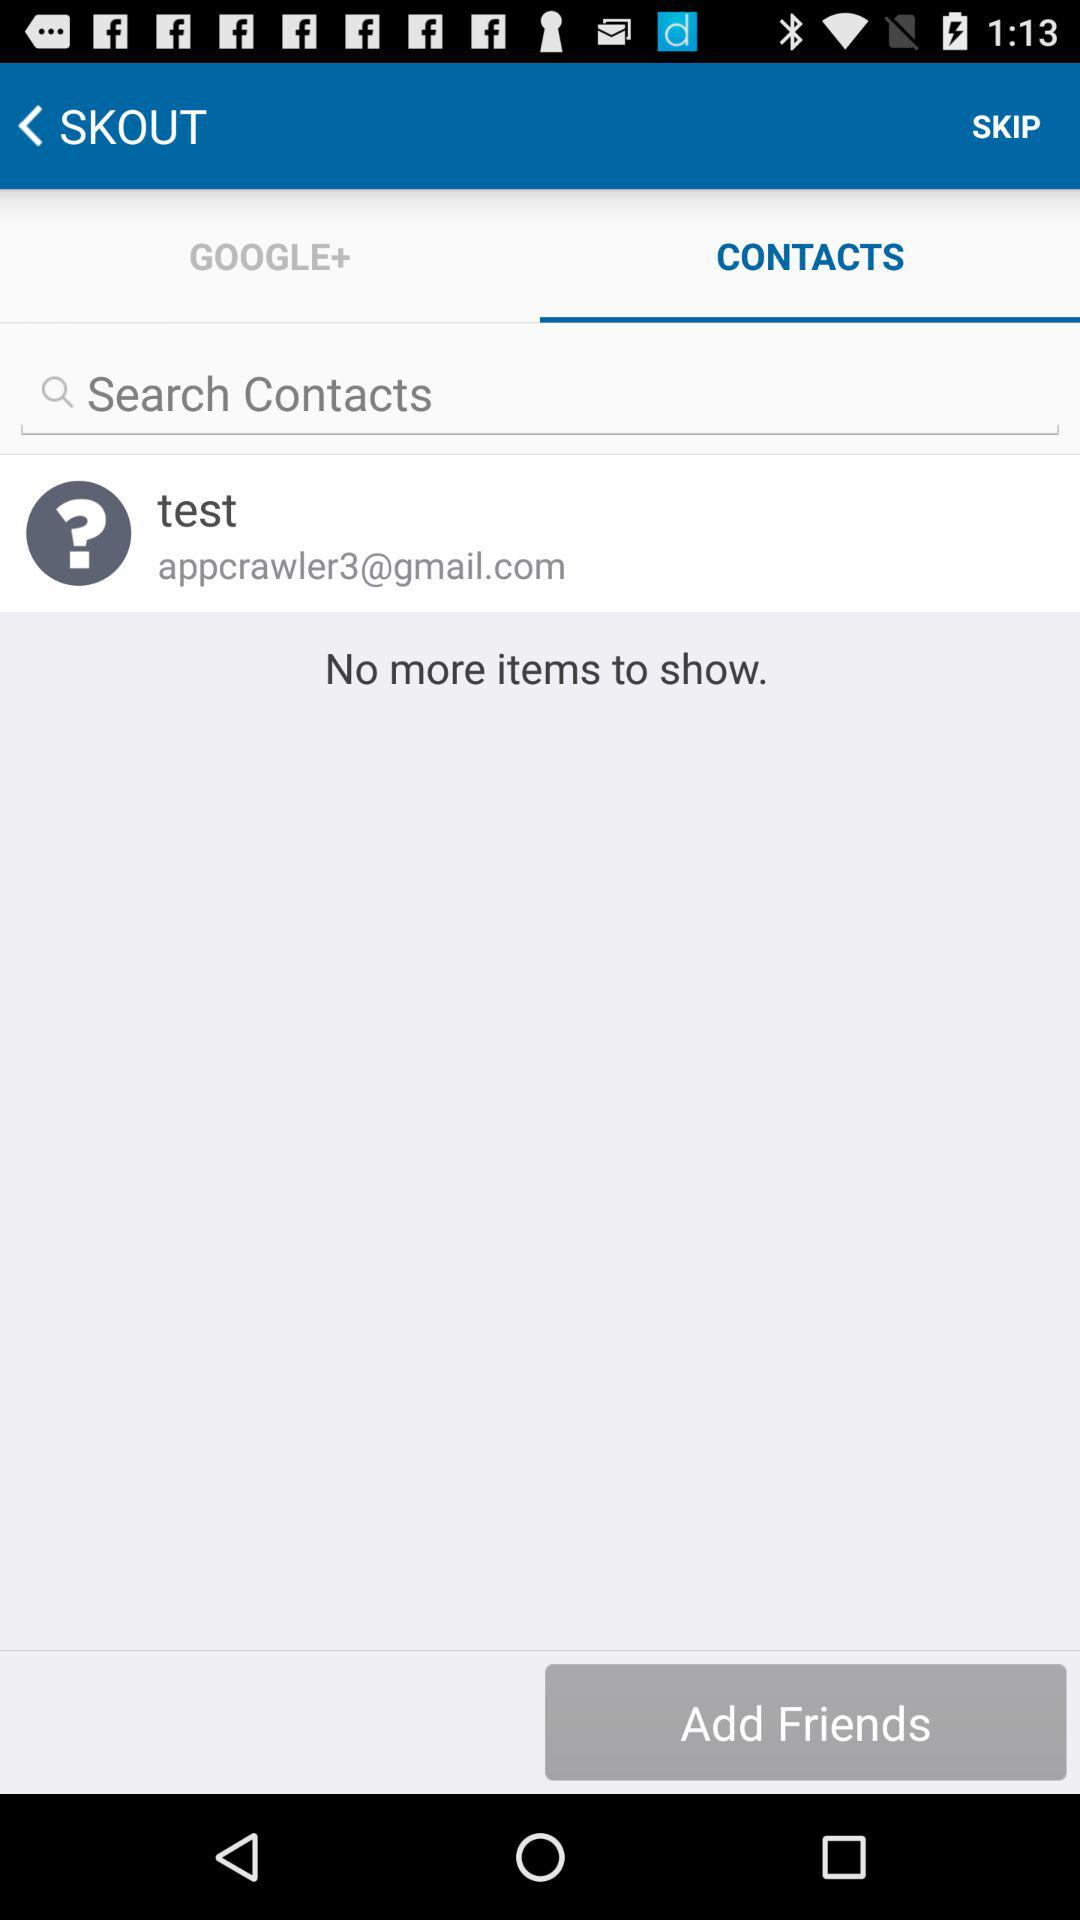Which tab is selected? The selected tab is "CONTACTS". 